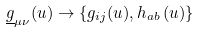<formula> <loc_0><loc_0><loc_500><loc_500>\underline { g } _ { \mu \nu } ( u ) \rightarrow \{ g _ { i j } ( u ) , h _ { a b } \left ( u \right ) \}</formula> 